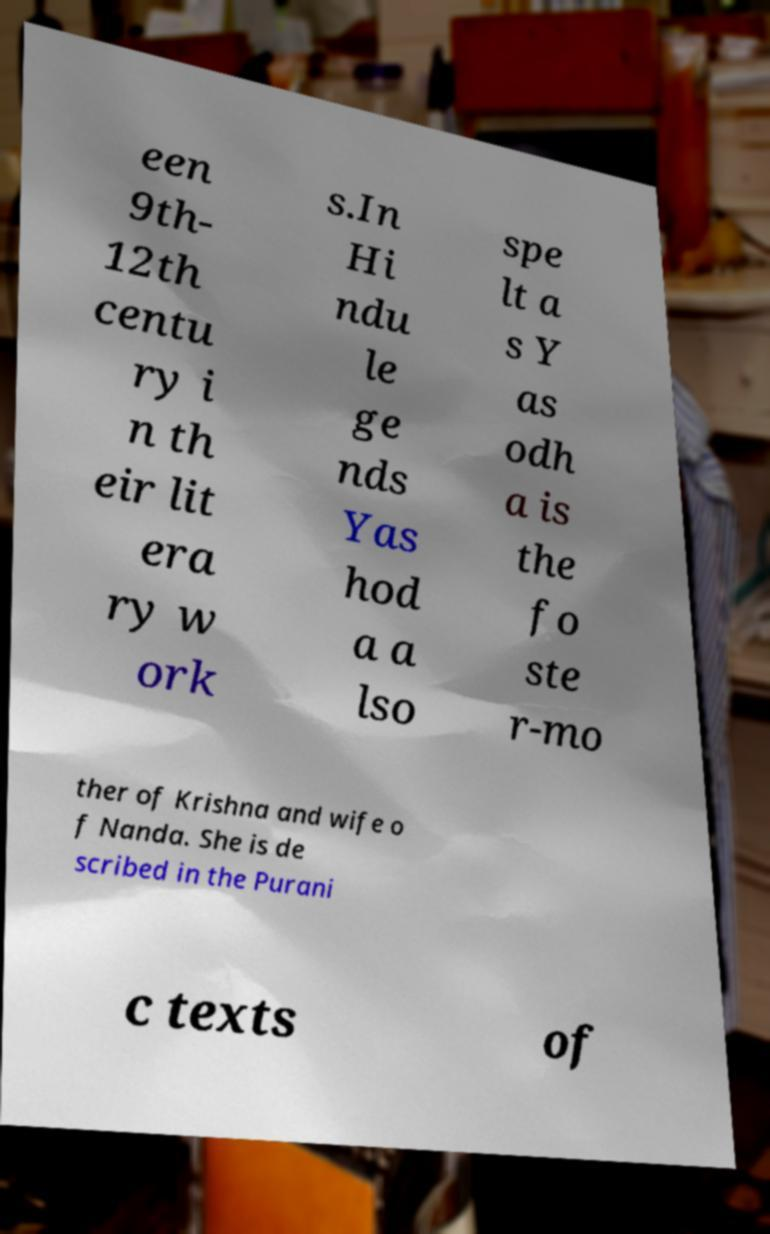Could you assist in decoding the text presented in this image and type it out clearly? een 9th- 12th centu ry i n th eir lit era ry w ork s.In Hi ndu le ge nds Yas hod a a lso spe lt a s Y as odh a is the fo ste r-mo ther of Krishna and wife o f Nanda. She is de scribed in the Purani c texts of 